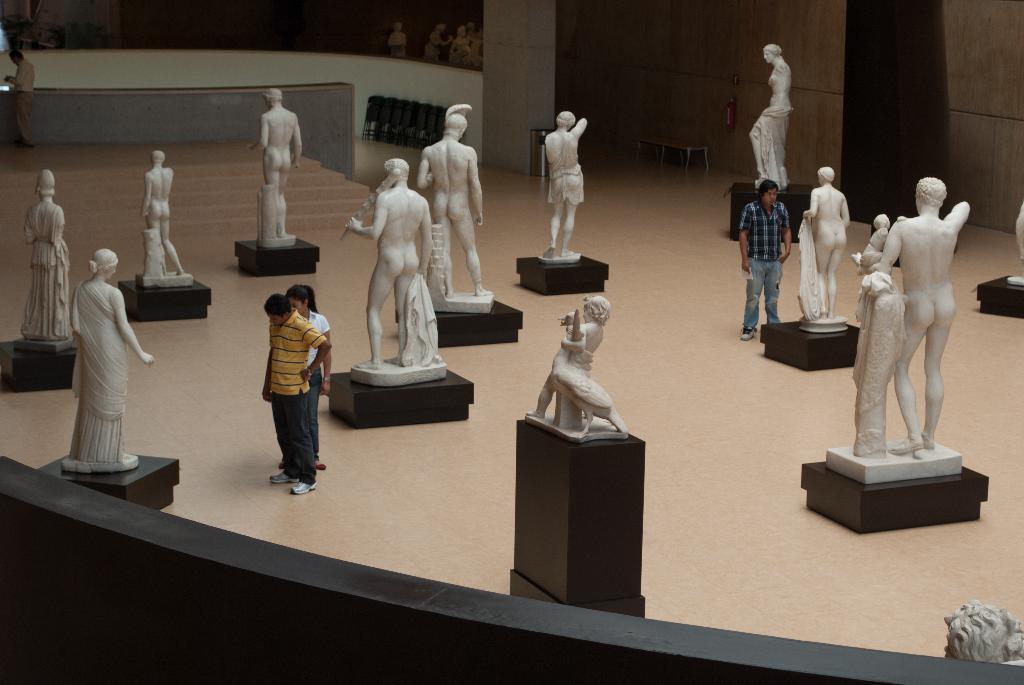Could you give a brief overview of what you see in this image? In this picture I can observe statues of human beings on the floor. There are some people in this picture. In the background there is a wall. 